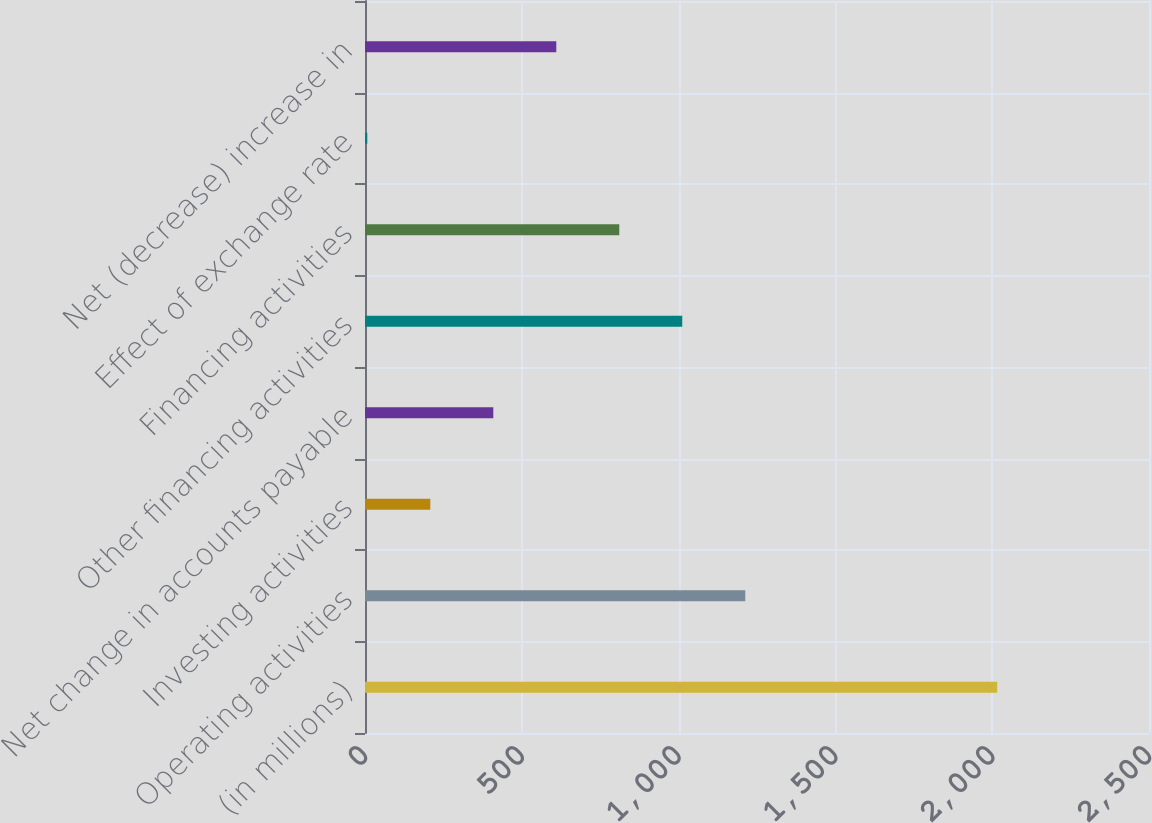Convert chart. <chart><loc_0><loc_0><loc_500><loc_500><bar_chart><fcel>(in millions)<fcel>Operating activities<fcel>Investing activities<fcel>Net change in accounts payable<fcel>Other financing activities<fcel>Financing activities<fcel>Effect of exchange rate<fcel>Net (decrease) increase in<nl><fcel>2016<fcel>1212.56<fcel>208.26<fcel>409.12<fcel>1011.7<fcel>810.84<fcel>7.4<fcel>609.98<nl></chart> 